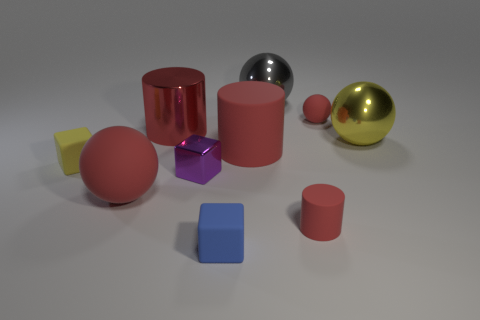Subtract all cubes. How many objects are left? 7 Add 6 yellow cylinders. How many yellow cylinders exist? 6 Subtract 3 red cylinders. How many objects are left? 7 Subtract all tiny green objects. Subtract all tiny matte things. How many objects are left? 6 Add 7 blue matte objects. How many blue matte objects are left? 8 